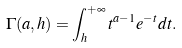<formula> <loc_0><loc_0><loc_500><loc_500>\Gamma ( a , h ) = \int _ { h } ^ { + \infty } t ^ { a - 1 } e ^ { - t } d t .</formula> 